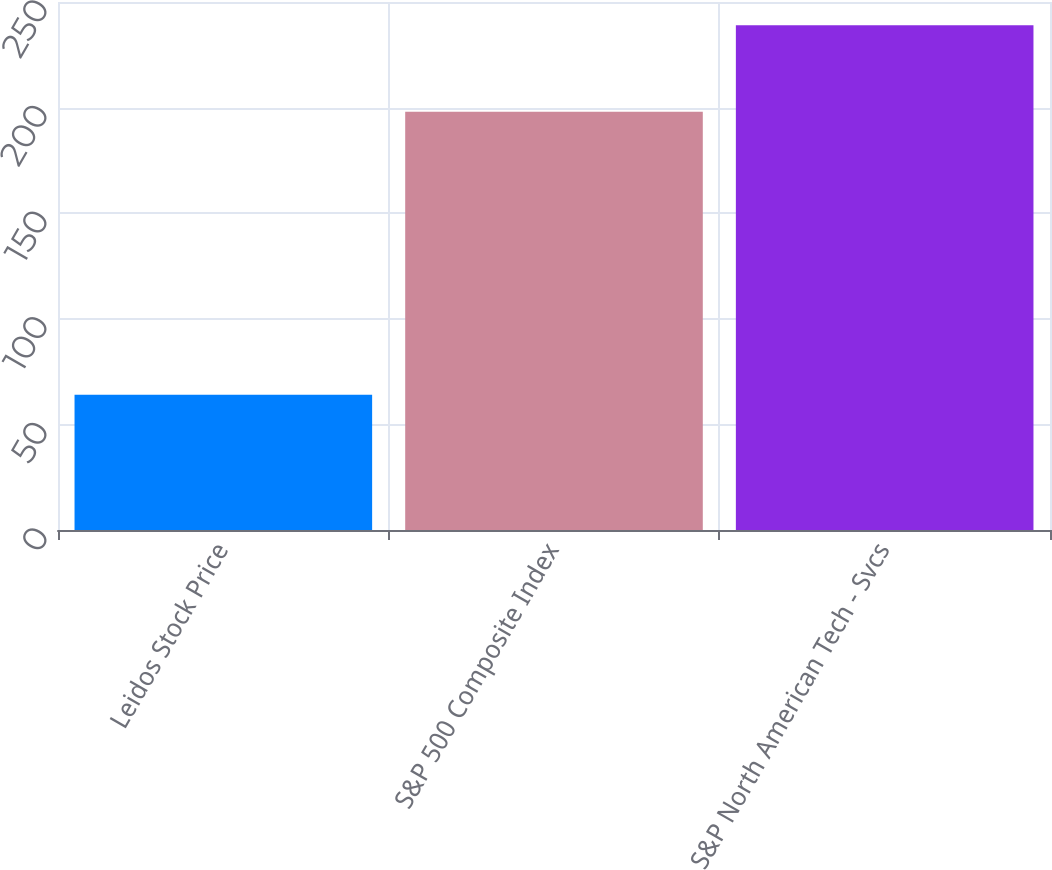Convert chart to OTSL. <chart><loc_0><loc_0><loc_500><loc_500><bar_chart><fcel>Leidos Stock Price<fcel>S&P 500 Composite Index<fcel>S&P North American Tech - Svcs<nl><fcel>64<fcel>198<fcel>239<nl></chart> 